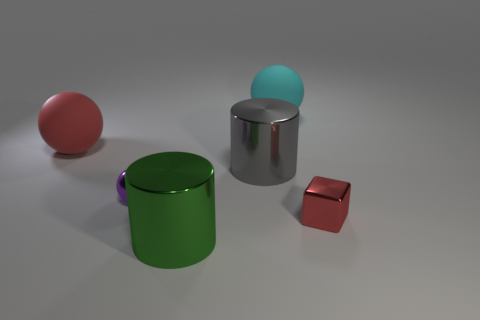Is there a cylinder made of the same material as the gray object?
Keep it short and to the point. Yes. The sphere that is to the left of the big cyan rubber object and right of the large red object is what color?
Provide a short and direct response. Purple. There is a large sphere that is in front of the big cyan sphere; what material is it?
Offer a very short reply. Rubber. Is there another gray metallic thing of the same shape as the gray object?
Your answer should be compact. No. What number of other things are the same shape as the gray thing?
Your answer should be very brief. 1. There is a large cyan matte object; is it the same shape as the red thing that is on the right side of the purple metal object?
Offer a terse response. No. There is a red object that is the same shape as the small purple thing; what is it made of?
Your answer should be compact. Rubber. How many tiny objects are green things or cyan metal blocks?
Your answer should be very brief. 0. Is the number of small balls that are on the right side of the gray metal cylinder less than the number of small shiny blocks that are to the left of the red shiny object?
Offer a terse response. No. How many objects are either tiny purple shiny spheres or red rubber cubes?
Keep it short and to the point. 1. 